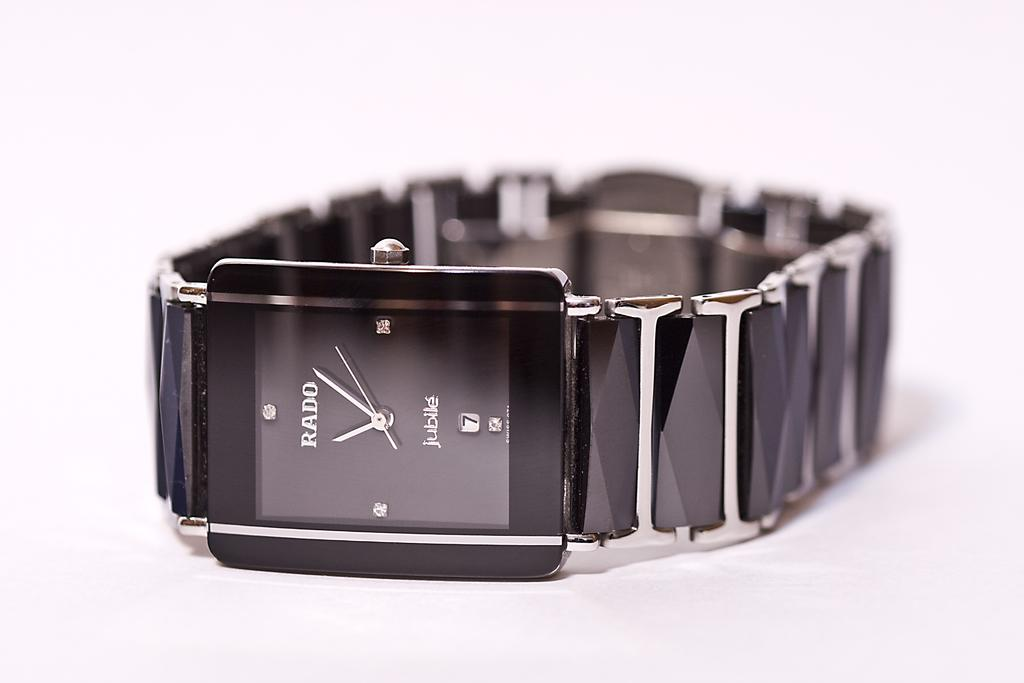<image>
Write a terse but informative summary of the picture. A sleek Rado Jubile watch laying on a white surface 